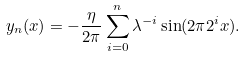Convert formula to latex. <formula><loc_0><loc_0><loc_500><loc_500>y _ { n } ( x ) = - \frac { \eta } { 2 \pi } \sum ^ { n } _ { i = 0 } \lambda ^ { - i } \sin ( 2 \pi 2 ^ { i } x ) .</formula> 